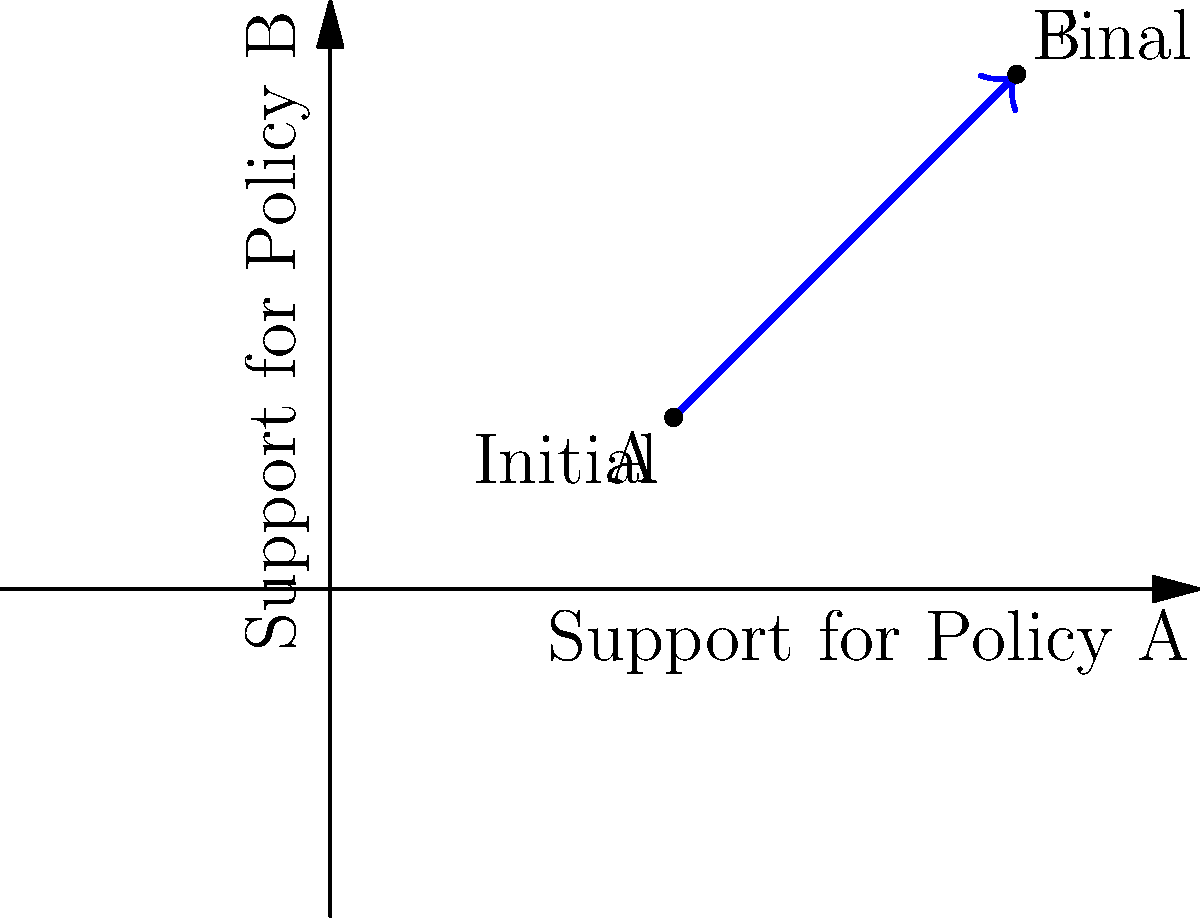As a policymaker, you're analyzing public opinion shifts on two major policies. The graph shows the change in support from point A to point B on a 2D plane, where the x-axis represents support for Policy A and the y-axis represents support for Policy B. What is the magnitude of the opinion shift vector, rounded to the nearest whole number? To find the magnitude of the opinion shift vector, we need to follow these steps:

1. Identify the change in x and y coordinates:
   - Change in x (Δx) = 4 - 2 = 2
   - Change in y (Δy) = 3 - 1 = 2

2. Use the vector magnitude formula:
   Magnitude = $\sqrt{(\Delta x)^2 + (\Delta y)^2}$

3. Substitute the values:
   Magnitude = $\sqrt{2^2 + 2^2}$

4. Simplify:
   Magnitude = $\sqrt{4 + 4}$ = $\sqrt{8}$

5. Calculate the square root:
   Magnitude ≈ 2.83

6. Round to the nearest whole number:
   2.83 rounds to 3

Therefore, the magnitude of the opinion shift vector, rounded to the nearest whole number, is 3.
Answer: 3 